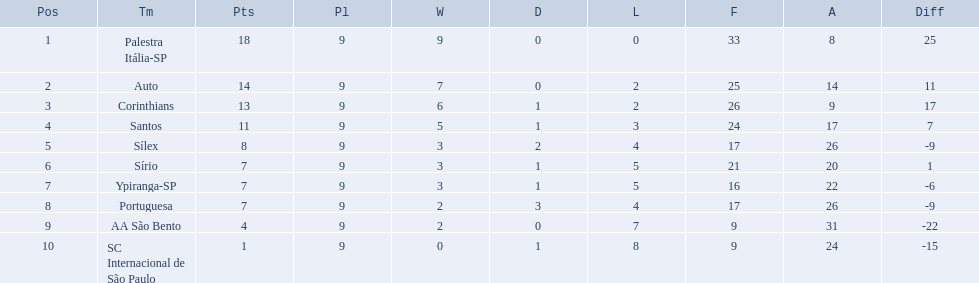How many teams played football in brazil during the year 1926? Palestra Itália-SP, Auto, Corinthians, Santos, Sílex, Sírio, Ypiranga-SP, Portuguesa, AA São Bento, SC Internacional de São Paulo. What was the highest number of games won during the 1926 season? 9. Which team was in the top spot with 9 wins for the 1926 season? Palestra Itália-SP. 